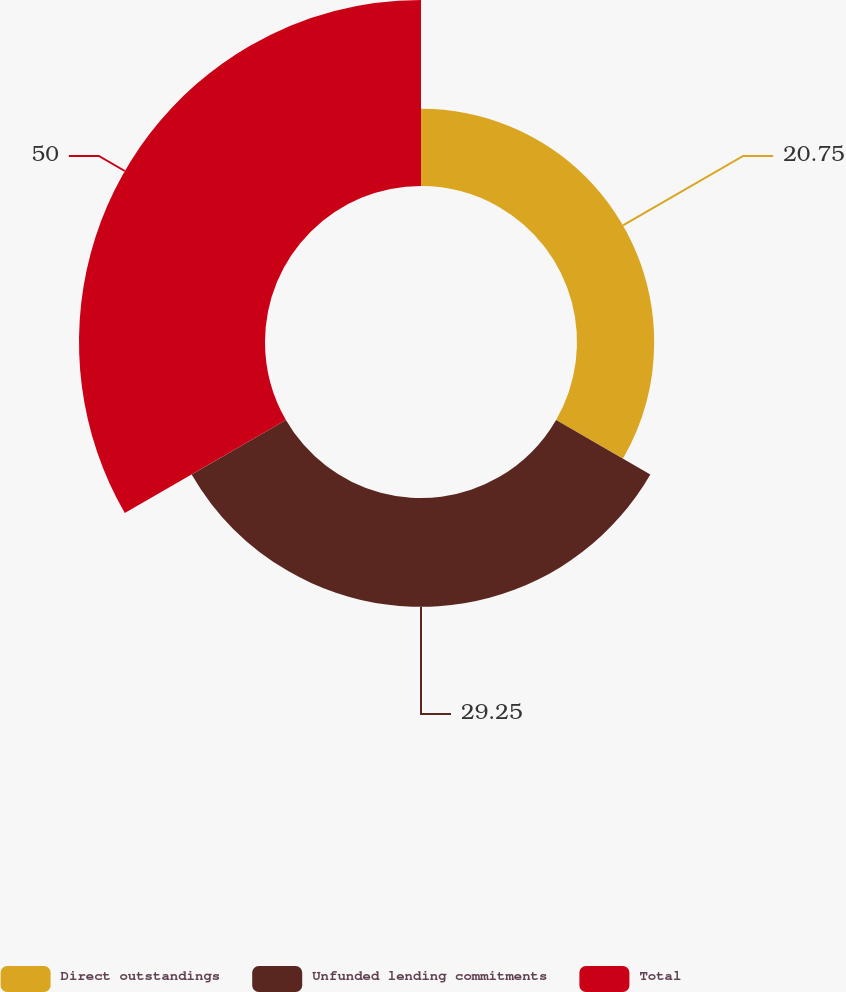Convert chart. <chart><loc_0><loc_0><loc_500><loc_500><pie_chart><fcel>Direct outstandings<fcel>Unfunded lending commitments<fcel>Total<nl><fcel>20.75%<fcel>29.25%<fcel>50.0%<nl></chart> 